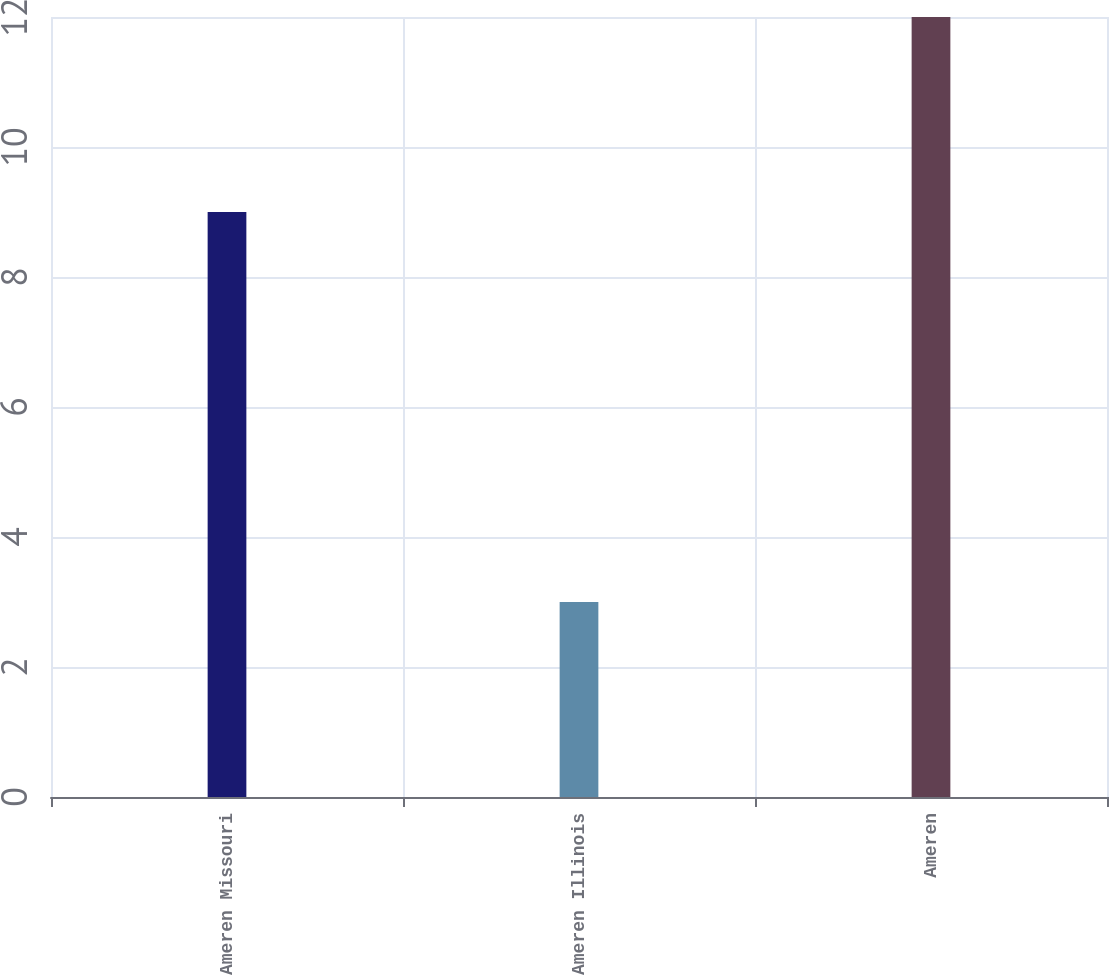Convert chart to OTSL. <chart><loc_0><loc_0><loc_500><loc_500><bar_chart><fcel>Ameren Missouri<fcel>Ameren Illinois<fcel>Ameren<nl><fcel>9<fcel>3<fcel>12<nl></chart> 